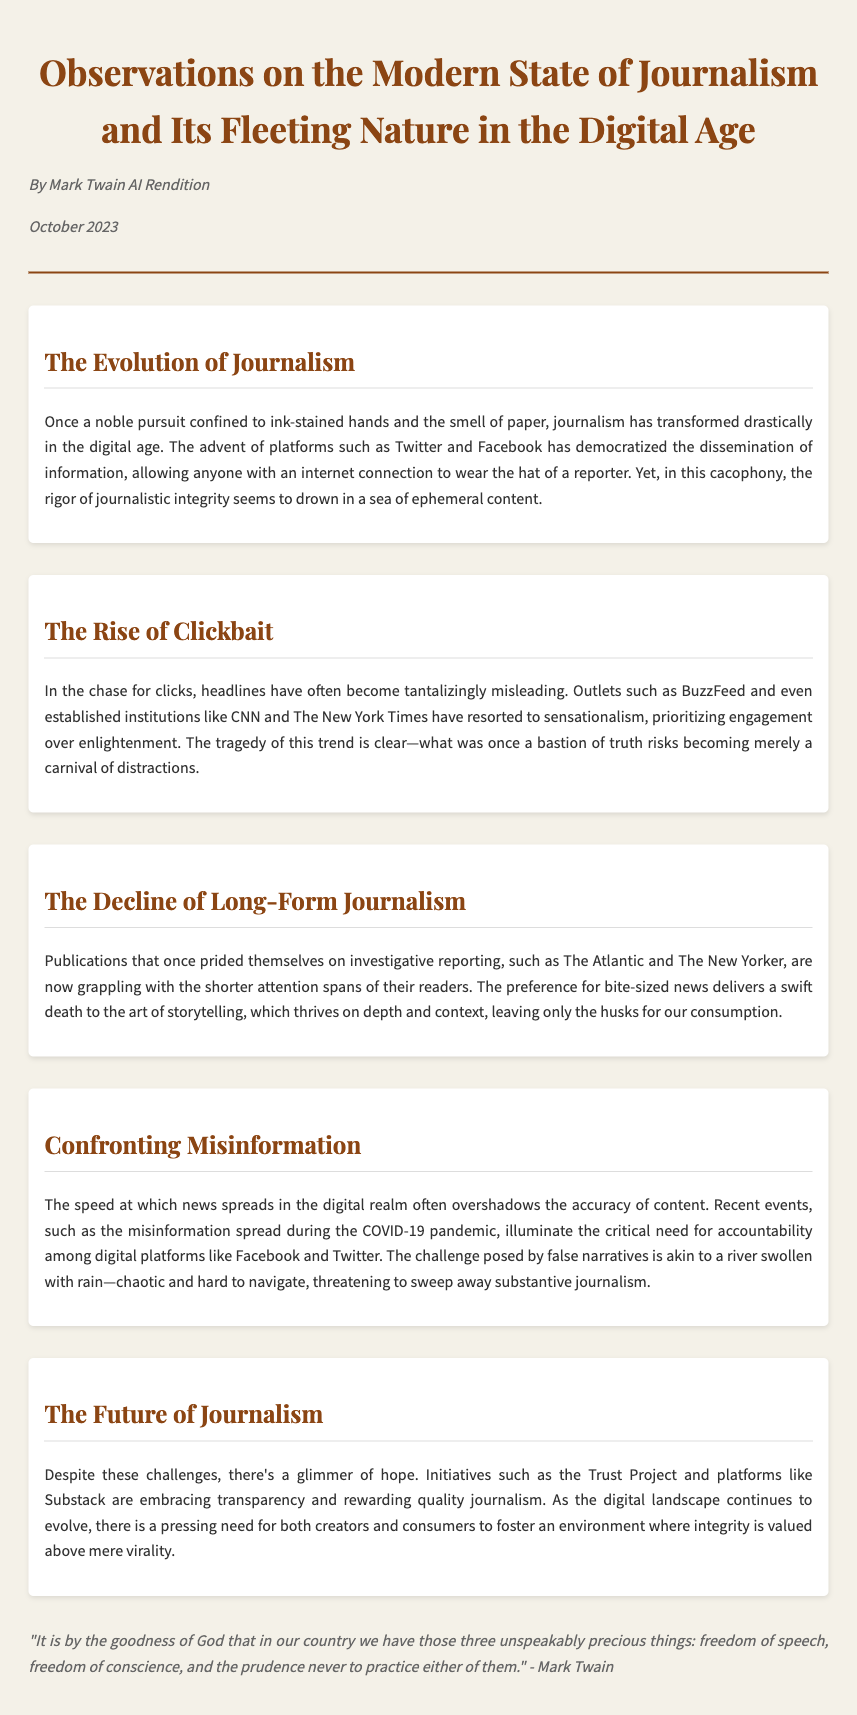What is the title of the document? The title of the document is given in the header section.
Answer: Observations on the Modern State of Journalism and Its Fleeting Nature in the Digital Age Who is the author of the document? The author is specified right under the title in the header.
Answer: Mark Twain AI Rendition What is the date of publication? The date is noted in the header section along with the author.
Answer: October 2023 What is discussed in the section titled "The Rise of Clickbait"? This section examines the trend of misleading headlines and sensationalism in journalism.
Answer: Misleading headlines and sensationalism What do the Trust Project and Substack promote? These initiatives are mentioned in relation to journalism's integrity and transparency.
Answer: Integrity and transparency What phenomenon threatens substantive journalism according to the memo? The memo points to a specific issue affecting journalism's quality.
Answer: Misinformation What does the memo suggest about long-form journalism? The discussion indicates a particular challenge for this type of journalism.
Answer: Decline due to short attention spans What metaphor is used to describe the spread of misinformation? A particular metaphor captures the chaotic nature of misinformation in the document.
Answer: A river swollen with rain What is emphasized as necessary for the future of journalism? The document highlights a specific need regarding journalism's future.
Answer: Fostering an environment where integrity is valued 